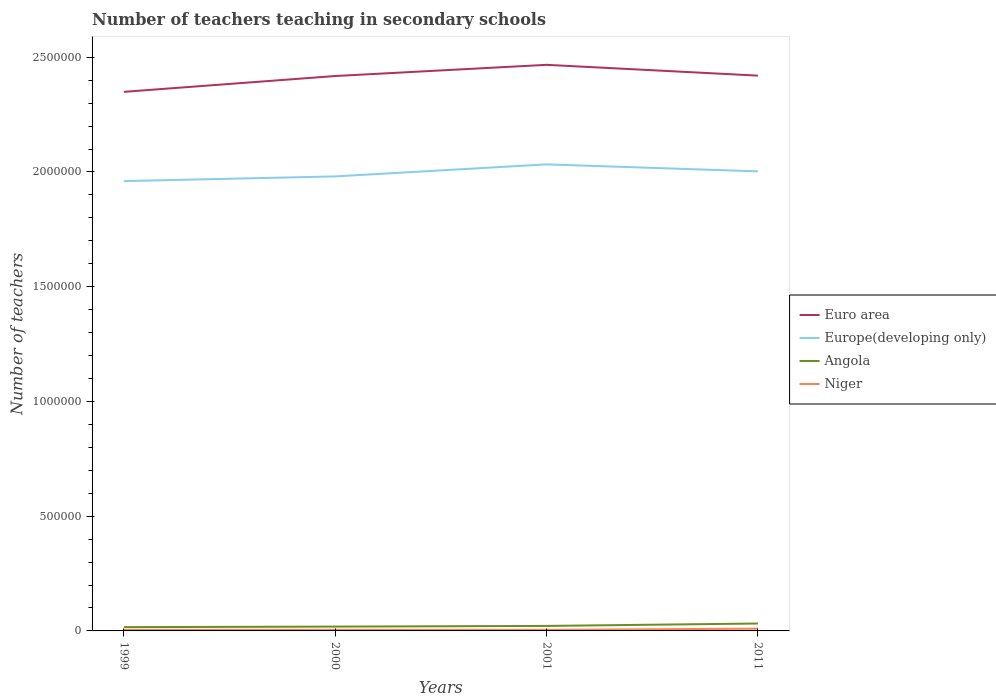Does the line corresponding to Euro area intersect with the line corresponding to Niger?
Provide a succinct answer. No. Across all years, what is the maximum number of teachers teaching in secondary schools in Euro area?
Give a very brief answer. 2.35e+06. What is the total number of teachers teaching in secondary schools in Angola in the graph?
Keep it short and to the point. -1.34e+04. What is the difference between the highest and the second highest number of teachers teaching in secondary schools in Euro area?
Your answer should be compact. 1.18e+05. Is the number of teachers teaching in secondary schools in Euro area strictly greater than the number of teachers teaching in secondary schools in Angola over the years?
Provide a short and direct response. No. How many years are there in the graph?
Make the answer very short. 4. Are the values on the major ticks of Y-axis written in scientific E-notation?
Offer a very short reply. No. How are the legend labels stacked?
Your answer should be compact. Vertical. What is the title of the graph?
Your answer should be compact. Number of teachers teaching in secondary schools. What is the label or title of the Y-axis?
Ensure brevity in your answer.  Number of teachers. What is the Number of teachers in Euro area in 1999?
Your response must be concise. 2.35e+06. What is the Number of teachers of Europe(developing only) in 1999?
Give a very brief answer. 1.96e+06. What is the Number of teachers in Angola in 1999?
Provide a succinct answer. 1.64e+04. What is the Number of teachers of Niger in 1999?
Give a very brief answer. 4303. What is the Number of teachers of Euro area in 2000?
Provide a short and direct response. 2.42e+06. What is the Number of teachers of Europe(developing only) in 2000?
Offer a very short reply. 1.98e+06. What is the Number of teachers of Angola in 2000?
Offer a very short reply. 1.88e+04. What is the Number of teachers in Niger in 2000?
Offer a very short reply. 4537. What is the Number of teachers of Euro area in 2001?
Provide a succinct answer. 2.47e+06. What is the Number of teachers in Europe(developing only) in 2001?
Give a very brief answer. 2.03e+06. What is the Number of teachers of Angola in 2001?
Provide a succinct answer. 2.18e+04. What is the Number of teachers in Niger in 2001?
Keep it short and to the point. 4589. What is the Number of teachers of Euro area in 2011?
Your response must be concise. 2.42e+06. What is the Number of teachers in Europe(developing only) in 2011?
Keep it short and to the point. 2.00e+06. What is the Number of teachers of Angola in 2011?
Make the answer very short. 3.23e+04. What is the Number of teachers in Niger in 2011?
Your answer should be very brief. 9873. Across all years, what is the maximum Number of teachers of Euro area?
Your answer should be compact. 2.47e+06. Across all years, what is the maximum Number of teachers in Europe(developing only)?
Your response must be concise. 2.03e+06. Across all years, what is the maximum Number of teachers of Angola?
Offer a terse response. 3.23e+04. Across all years, what is the maximum Number of teachers of Niger?
Offer a very short reply. 9873. Across all years, what is the minimum Number of teachers in Euro area?
Offer a very short reply. 2.35e+06. Across all years, what is the minimum Number of teachers of Europe(developing only)?
Make the answer very short. 1.96e+06. Across all years, what is the minimum Number of teachers of Angola?
Offer a very short reply. 1.64e+04. Across all years, what is the minimum Number of teachers in Niger?
Make the answer very short. 4303. What is the total Number of teachers of Euro area in the graph?
Your answer should be compact. 9.65e+06. What is the total Number of teachers in Europe(developing only) in the graph?
Keep it short and to the point. 7.98e+06. What is the total Number of teachers of Angola in the graph?
Offer a terse response. 8.94e+04. What is the total Number of teachers in Niger in the graph?
Ensure brevity in your answer.  2.33e+04. What is the difference between the Number of teachers of Euro area in 1999 and that in 2000?
Provide a short and direct response. -6.90e+04. What is the difference between the Number of teachers in Europe(developing only) in 1999 and that in 2000?
Provide a succinct answer. -2.05e+04. What is the difference between the Number of teachers in Angola in 1999 and that in 2000?
Provide a succinct answer. -2401. What is the difference between the Number of teachers of Niger in 1999 and that in 2000?
Your answer should be compact. -234. What is the difference between the Number of teachers of Euro area in 1999 and that in 2001?
Offer a very short reply. -1.18e+05. What is the difference between the Number of teachers of Europe(developing only) in 1999 and that in 2001?
Make the answer very short. -7.29e+04. What is the difference between the Number of teachers in Angola in 1999 and that in 2001?
Provide a short and direct response. -5371. What is the difference between the Number of teachers of Niger in 1999 and that in 2001?
Your answer should be compact. -286. What is the difference between the Number of teachers of Euro area in 1999 and that in 2011?
Give a very brief answer. -7.07e+04. What is the difference between the Number of teachers in Europe(developing only) in 1999 and that in 2011?
Give a very brief answer. -4.25e+04. What is the difference between the Number of teachers of Angola in 1999 and that in 2011?
Your answer should be very brief. -1.58e+04. What is the difference between the Number of teachers in Niger in 1999 and that in 2011?
Offer a very short reply. -5570. What is the difference between the Number of teachers of Euro area in 2000 and that in 2001?
Offer a very short reply. -4.88e+04. What is the difference between the Number of teachers in Europe(developing only) in 2000 and that in 2001?
Your response must be concise. -5.24e+04. What is the difference between the Number of teachers in Angola in 2000 and that in 2001?
Your answer should be compact. -2970. What is the difference between the Number of teachers of Niger in 2000 and that in 2001?
Keep it short and to the point. -52. What is the difference between the Number of teachers of Euro area in 2000 and that in 2011?
Ensure brevity in your answer.  -1714.25. What is the difference between the Number of teachers in Europe(developing only) in 2000 and that in 2011?
Offer a terse response. -2.20e+04. What is the difference between the Number of teachers in Angola in 2000 and that in 2011?
Provide a succinct answer. -1.34e+04. What is the difference between the Number of teachers of Niger in 2000 and that in 2011?
Your answer should be compact. -5336. What is the difference between the Number of teachers in Euro area in 2001 and that in 2011?
Provide a short and direct response. 4.71e+04. What is the difference between the Number of teachers in Europe(developing only) in 2001 and that in 2011?
Ensure brevity in your answer.  3.04e+04. What is the difference between the Number of teachers of Angola in 2001 and that in 2011?
Offer a terse response. -1.05e+04. What is the difference between the Number of teachers of Niger in 2001 and that in 2011?
Give a very brief answer. -5284. What is the difference between the Number of teachers in Euro area in 1999 and the Number of teachers in Europe(developing only) in 2000?
Provide a short and direct response. 3.68e+05. What is the difference between the Number of teachers of Euro area in 1999 and the Number of teachers of Angola in 2000?
Make the answer very short. 2.33e+06. What is the difference between the Number of teachers in Euro area in 1999 and the Number of teachers in Niger in 2000?
Make the answer very short. 2.34e+06. What is the difference between the Number of teachers in Europe(developing only) in 1999 and the Number of teachers in Angola in 2000?
Provide a succinct answer. 1.94e+06. What is the difference between the Number of teachers in Europe(developing only) in 1999 and the Number of teachers in Niger in 2000?
Ensure brevity in your answer.  1.96e+06. What is the difference between the Number of teachers in Angola in 1999 and the Number of teachers in Niger in 2000?
Your response must be concise. 1.19e+04. What is the difference between the Number of teachers of Euro area in 1999 and the Number of teachers of Europe(developing only) in 2001?
Provide a short and direct response. 3.16e+05. What is the difference between the Number of teachers of Euro area in 1999 and the Number of teachers of Angola in 2001?
Give a very brief answer. 2.33e+06. What is the difference between the Number of teachers of Euro area in 1999 and the Number of teachers of Niger in 2001?
Offer a very short reply. 2.34e+06. What is the difference between the Number of teachers of Europe(developing only) in 1999 and the Number of teachers of Angola in 2001?
Your response must be concise. 1.94e+06. What is the difference between the Number of teachers in Europe(developing only) in 1999 and the Number of teachers in Niger in 2001?
Your answer should be very brief. 1.96e+06. What is the difference between the Number of teachers in Angola in 1999 and the Number of teachers in Niger in 2001?
Make the answer very short. 1.19e+04. What is the difference between the Number of teachers of Euro area in 1999 and the Number of teachers of Europe(developing only) in 2011?
Give a very brief answer. 3.46e+05. What is the difference between the Number of teachers in Euro area in 1999 and the Number of teachers in Angola in 2011?
Provide a succinct answer. 2.32e+06. What is the difference between the Number of teachers of Euro area in 1999 and the Number of teachers of Niger in 2011?
Offer a very short reply. 2.34e+06. What is the difference between the Number of teachers of Europe(developing only) in 1999 and the Number of teachers of Angola in 2011?
Offer a terse response. 1.93e+06. What is the difference between the Number of teachers of Europe(developing only) in 1999 and the Number of teachers of Niger in 2011?
Make the answer very short. 1.95e+06. What is the difference between the Number of teachers in Angola in 1999 and the Number of teachers in Niger in 2011?
Provide a succinct answer. 6574. What is the difference between the Number of teachers in Euro area in 2000 and the Number of teachers in Europe(developing only) in 2001?
Give a very brief answer. 3.85e+05. What is the difference between the Number of teachers in Euro area in 2000 and the Number of teachers in Angola in 2001?
Provide a succinct answer. 2.40e+06. What is the difference between the Number of teachers of Euro area in 2000 and the Number of teachers of Niger in 2001?
Offer a very short reply. 2.41e+06. What is the difference between the Number of teachers of Europe(developing only) in 2000 and the Number of teachers of Angola in 2001?
Ensure brevity in your answer.  1.96e+06. What is the difference between the Number of teachers in Europe(developing only) in 2000 and the Number of teachers in Niger in 2001?
Offer a terse response. 1.98e+06. What is the difference between the Number of teachers of Angola in 2000 and the Number of teachers of Niger in 2001?
Your response must be concise. 1.43e+04. What is the difference between the Number of teachers of Euro area in 2000 and the Number of teachers of Europe(developing only) in 2011?
Make the answer very short. 4.15e+05. What is the difference between the Number of teachers of Euro area in 2000 and the Number of teachers of Angola in 2011?
Offer a terse response. 2.39e+06. What is the difference between the Number of teachers in Euro area in 2000 and the Number of teachers in Niger in 2011?
Offer a terse response. 2.41e+06. What is the difference between the Number of teachers in Europe(developing only) in 2000 and the Number of teachers in Angola in 2011?
Your response must be concise. 1.95e+06. What is the difference between the Number of teachers of Europe(developing only) in 2000 and the Number of teachers of Niger in 2011?
Provide a short and direct response. 1.97e+06. What is the difference between the Number of teachers in Angola in 2000 and the Number of teachers in Niger in 2011?
Your answer should be very brief. 8975. What is the difference between the Number of teachers in Euro area in 2001 and the Number of teachers in Europe(developing only) in 2011?
Your answer should be compact. 4.64e+05. What is the difference between the Number of teachers in Euro area in 2001 and the Number of teachers in Angola in 2011?
Give a very brief answer. 2.43e+06. What is the difference between the Number of teachers of Euro area in 2001 and the Number of teachers of Niger in 2011?
Offer a very short reply. 2.46e+06. What is the difference between the Number of teachers in Europe(developing only) in 2001 and the Number of teachers in Angola in 2011?
Your response must be concise. 2.00e+06. What is the difference between the Number of teachers of Europe(developing only) in 2001 and the Number of teachers of Niger in 2011?
Your answer should be very brief. 2.02e+06. What is the difference between the Number of teachers of Angola in 2001 and the Number of teachers of Niger in 2011?
Make the answer very short. 1.19e+04. What is the average Number of teachers in Euro area per year?
Provide a succinct answer. 2.41e+06. What is the average Number of teachers of Europe(developing only) per year?
Your answer should be compact. 1.99e+06. What is the average Number of teachers of Angola per year?
Keep it short and to the point. 2.23e+04. What is the average Number of teachers of Niger per year?
Keep it short and to the point. 5825.5. In the year 1999, what is the difference between the Number of teachers of Euro area and Number of teachers of Europe(developing only)?
Make the answer very short. 3.89e+05. In the year 1999, what is the difference between the Number of teachers in Euro area and Number of teachers in Angola?
Ensure brevity in your answer.  2.33e+06. In the year 1999, what is the difference between the Number of teachers of Euro area and Number of teachers of Niger?
Give a very brief answer. 2.34e+06. In the year 1999, what is the difference between the Number of teachers in Europe(developing only) and Number of teachers in Angola?
Give a very brief answer. 1.94e+06. In the year 1999, what is the difference between the Number of teachers in Europe(developing only) and Number of teachers in Niger?
Your answer should be compact. 1.96e+06. In the year 1999, what is the difference between the Number of teachers of Angola and Number of teachers of Niger?
Provide a succinct answer. 1.21e+04. In the year 2000, what is the difference between the Number of teachers in Euro area and Number of teachers in Europe(developing only)?
Provide a short and direct response. 4.37e+05. In the year 2000, what is the difference between the Number of teachers of Euro area and Number of teachers of Angola?
Keep it short and to the point. 2.40e+06. In the year 2000, what is the difference between the Number of teachers in Euro area and Number of teachers in Niger?
Provide a succinct answer. 2.41e+06. In the year 2000, what is the difference between the Number of teachers in Europe(developing only) and Number of teachers in Angola?
Make the answer very short. 1.96e+06. In the year 2000, what is the difference between the Number of teachers of Europe(developing only) and Number of teachers of Niger?
Your answer should be compact. 1.98e+06. In the year 2000, what is the difference between the Number of teachers in Angola and Number of teachers in Niger?
Your answer should be very brief. 1.43e+04. In the year 2001, what is the difference between the Number of teachers in Euro area and Number of teachers in Europe(developing only)?
Make the answer very short. 4.34e+05. In the year 2001, what is the difference between the Number of teachers in Euro area and Number of teachers in Angola?
Your answer should be very brief. 2.44e+06. In the year 2001, what is the difference between the Number of teachers of Euro area and Number of teachers of Niger?
Your answer should be compact. 2.46e+06. In the year 2001, what is the difference between the Number of teachers in Europe(developing only) and Number of teachers in Angola?
Make the answer very short. 2.01e+06. In the year 2001, what is the difference between the Number of teachers in Europe(developing only) and Number of teachers in Niger?
Give a very brief answer. 2.03e+06. In the year 2001, what is the difference between the Number of teachers of Angola and Number of teachers of Niger?
Provide a short and direct response. 1.72e+04. In the year 2011, what is the difference between the Number of teachers in Euro area and Number of teachers in Europe(developing only)?
Your answer should be compact. 4.17e+05. In the year 2011, what is the difference between the Number of teachers of Euro area and Number of teachers of Angola?
Offer a terse response. 2.39e+06. In the year 2011, what is the difference between the Number of teachers of Euro area and Number of teachers of Niger?
Offer a terse response. 2.41e+06. In the year 2011, what is the difference between the Number of teachers in Europe(developing only) and Number of teachers in Angola?
Provide a succinct answer. 1.97e+06. In the year 2011, what is the difference between the Number of teachers of Europe(developing only) and Number of teachers of Niger?
Offer a very short reply. 1.99e+06. In the year 2011, what is the difference between the Number of teachers of Angola and Number of teachers of Niger?
Keep it short and to the point. 2.24e+04. What is the ratio of the Number of teachers of Euro area in 1999 to that in 2000?
Keep it short and to the point. 0.97. What is the ratio of the Number of teachers of Angola in 1999 to that in 2000?
Give a very brief answer. 0.87. What is the ratio of the Number of teachers of Niger in 1999 to that in 2000?
Offer a very short reply. 0.95. What is the ratio of the Number of teachers in Euro area in 1999 to that in 2001?
Your response must be concise. 0.95. What is the ratio of the Number of teachers in Europe(developing only) in 1999 to that in 2001?
Provide a short and direct response. 0.96. What is the ratio of the Number of teachers in Angola in 1999 to that in 2001?
Make the answer very short. 0.75. What is the ratio of the Number of teachers of Niger in 1999 to that in 2001?
Provide a short and direct response. 0.94. What is the ratio of the Number of teachers of Euro area in 1999 to that in 2011?
Make the answer very short. 0.97. What is the ratio of the Number of teachers in Europe(developing only) in 1999 to that in 2011?
Provide a short and direct response. 0.98. What is the ratio of the Number of teachers of Angola in 1999 to that in 2011?
Provide a succinct answer. 0.51. What is the ratio of the Number of teachers in Niger in 1999 to that in 2011?
Ensure brevity in your answer.  0.44. What is the ratio of the Number of teachers of Euro area in 2000 to that in 2001?
Make the answer very short. 0.98. What is the ratio of the Number of teachers of Europe(developing only) in 2000 to that in 2001?
Your response must be concise. 0.97. What is the ratio of the Number of teachers in Angola in 2000 to that in 2001?
Provide a short and direct response. 0.86. What is the ratio of the Number of teachers of Niger in 2000 to that in 2001?
Give a very brief answer. 0.99. What is the ratio of the Number of teachers of Europe(developing only) in 2000 to that in 2011?
Your answer should be compact. 0.99. What is the ratio of the Number of teachers of Angola in 2000 to that in 2011?
Your response must be concise. 0.58. What is the ratio of the Number of teachers in Niger in 2000 to that in 2011?
Your answer should be very brief. 0.46. What is the ratio of the Number of teachers in Euro area in 2001 to that in 2011?
Provide a short and direct response. 1.02. What is the ratio of the Number of teachers of Europe(developing only) in 2001 to that in 2011?
Your response must be concise. 1.02. What is the ratio of the Number of teachers of Angola in 2001 to that in 2011?
Offer a very short reply. 0.68. What is the ratio of the Number of teachers in Niger in 2001 to that in 2011?
Keep it short and to the point. 0.46. What is the difference between the highest and the second highest Number of teachers of Euro area?
Offer a terse response. 4.71e+04. What is the difference between the highest and the second highest Number of teachers of Europe(developing only)?
Offer a terse response. 3.04e+04. What is the difference between the highest and the second highest Number of teachers in Angola?
Provide a succinct answer. 1.05e+04. What is the difference between the highest and the second highest Number of teachers in Niger?
Provide a short and direct response. 5284. What is the difference between the highest and the lowest Number of teachers of Euro area?
Your answer should be compact. 1.18e+05. What is the difference between the highest and the lowest Number of teachers of Europe(developing only)?
Offer a terse response. 7.29e+04. What is the difference between the highest and the lowest Number of teachers of Angola?
Provide a succinct answer. 1.58e+04. What is the difference between the highest and the lowest Number of teachers in Niger?
Provide a short and direct response. 5570. 